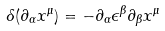Convert formula to latex. <formula><loc_0><loc_0><loc_500><loc_500>\delta ( \partial _ { \alpha } x ^ { \mu } ) = - \partial _ { \alpha } \epsilon ^ { \beta } \partial _ { \beta } x ^ { \mu }</formula> 